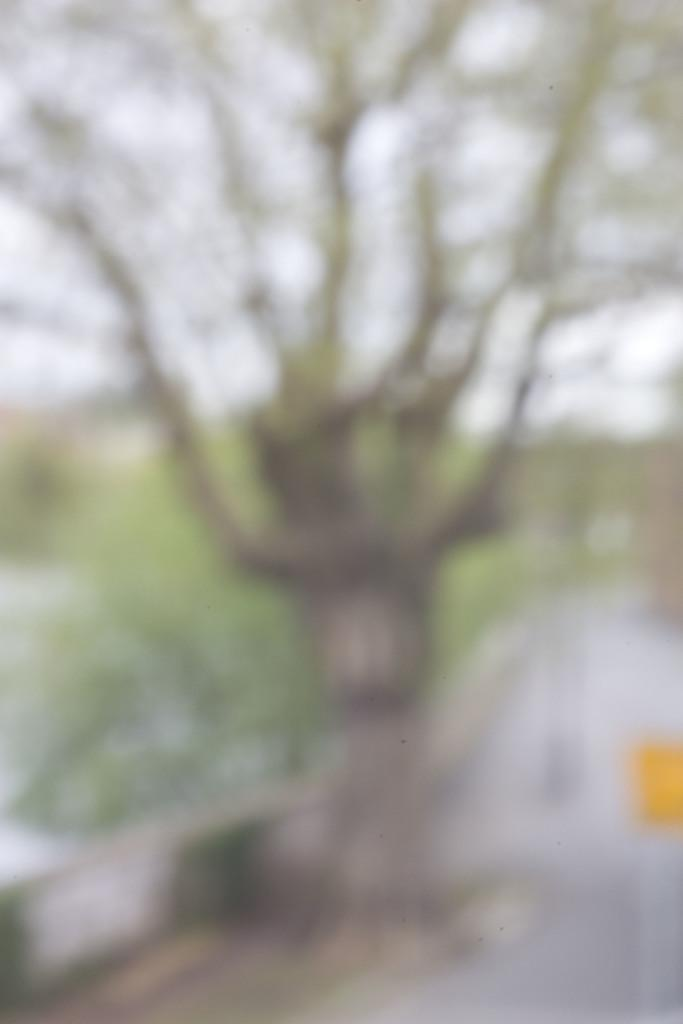What type of natural element can be seen in the image? There is a tree in the image. Can you describe the tree in the image? The provided facts do not give specific details about the tree, so we cannot describe it further. What type of kite can be seen flying near the tree in the image? There is no kite present in the image; it only features a tree. What type of can is visible on the tree in the image? There is no can present in the image; it only features a tree. What type of rhythm can be heard coming from the tree in the image? There is no sound or rhythm associated with the tree in the image. 